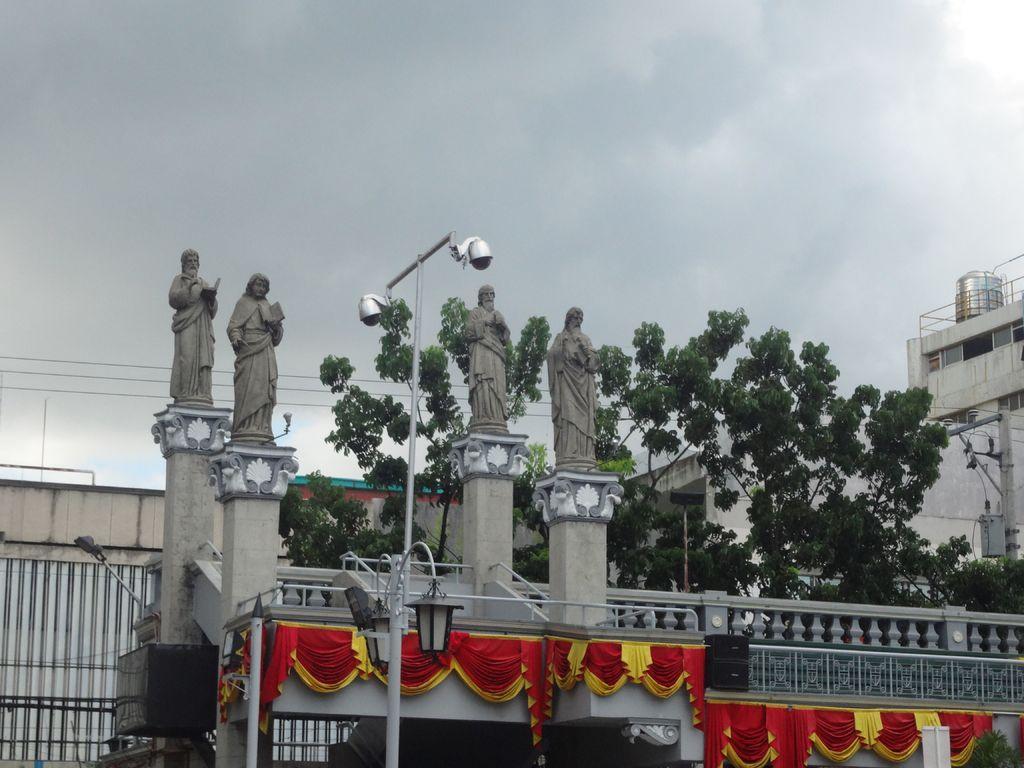In one or two sentences, can you explain what this image depicts? In the image we can see there are four sculptures of people. There is a light pole, sound box, fence, electric wire, trees, building and a cloudy sky. This is a decorative cloth. 